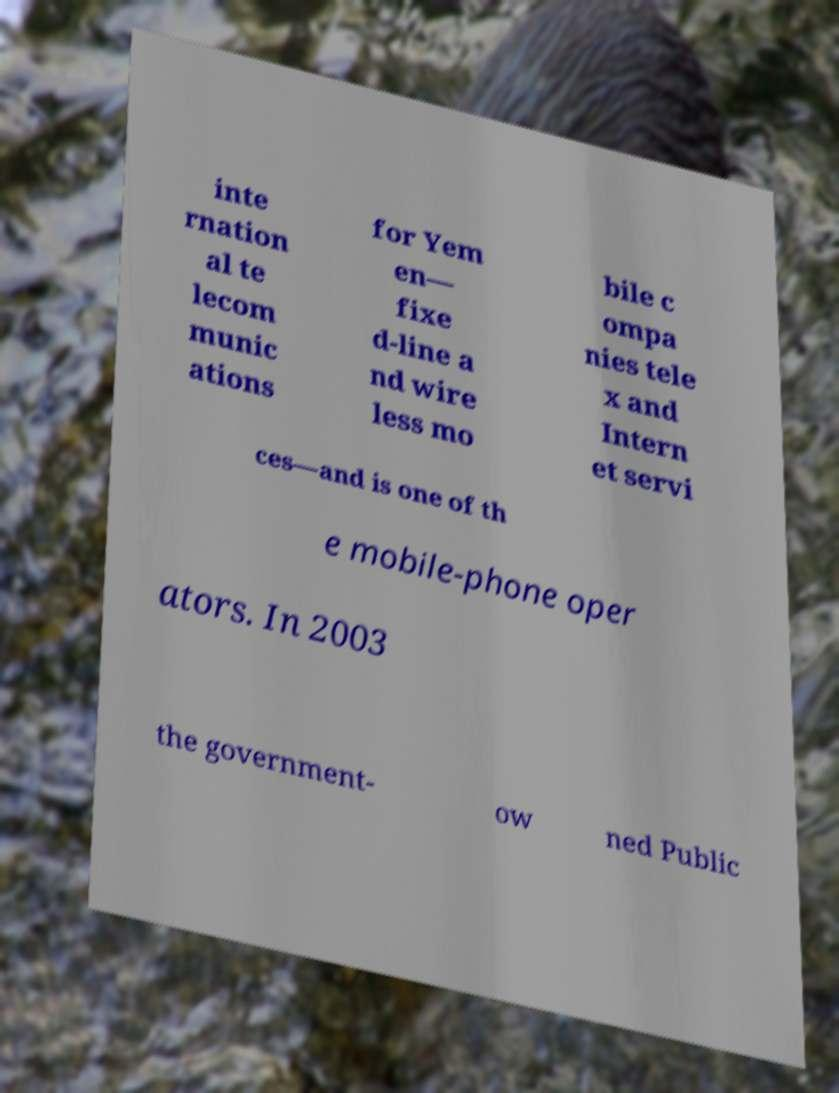Could you extract and type out the text from this image? inte rnation al te lecom munic ations for Yem en— fixe d-line a nd wire less mo bile c ompa nies tele x and Intern et servi ces—and is one of th e mobile-phone oper ators. In 2003 the government- ow ned Public 